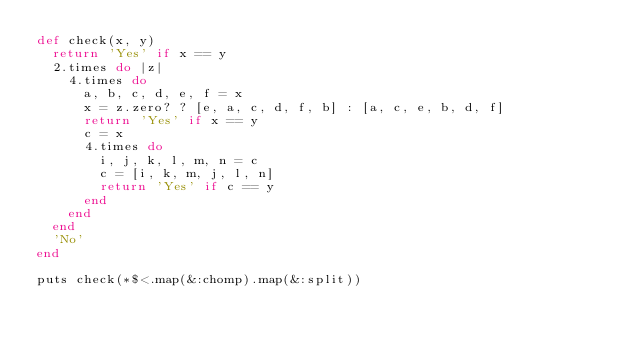<code> <loc_0><loc_0><loc_500><loc_500><_Ruby_>def check(x, y)
  return 'Yes' if x == y
  2.times do |z|
    4.times do
      a, b, c, d, e, f = x
      x = z.zero? ? [e, a, c, d, f, b] : [a, c, e, b, d, f]
      return 'Yes' if x == y
      c = x
      4.times do
        i, j, k, l, m, n = c
        c = [i, k, m, j, l, n]
        return 'Yes' if c == y
      end
    end
  end
  'No'
end

puts check(*$<.map(&:chomp).map(&:split))</code> 